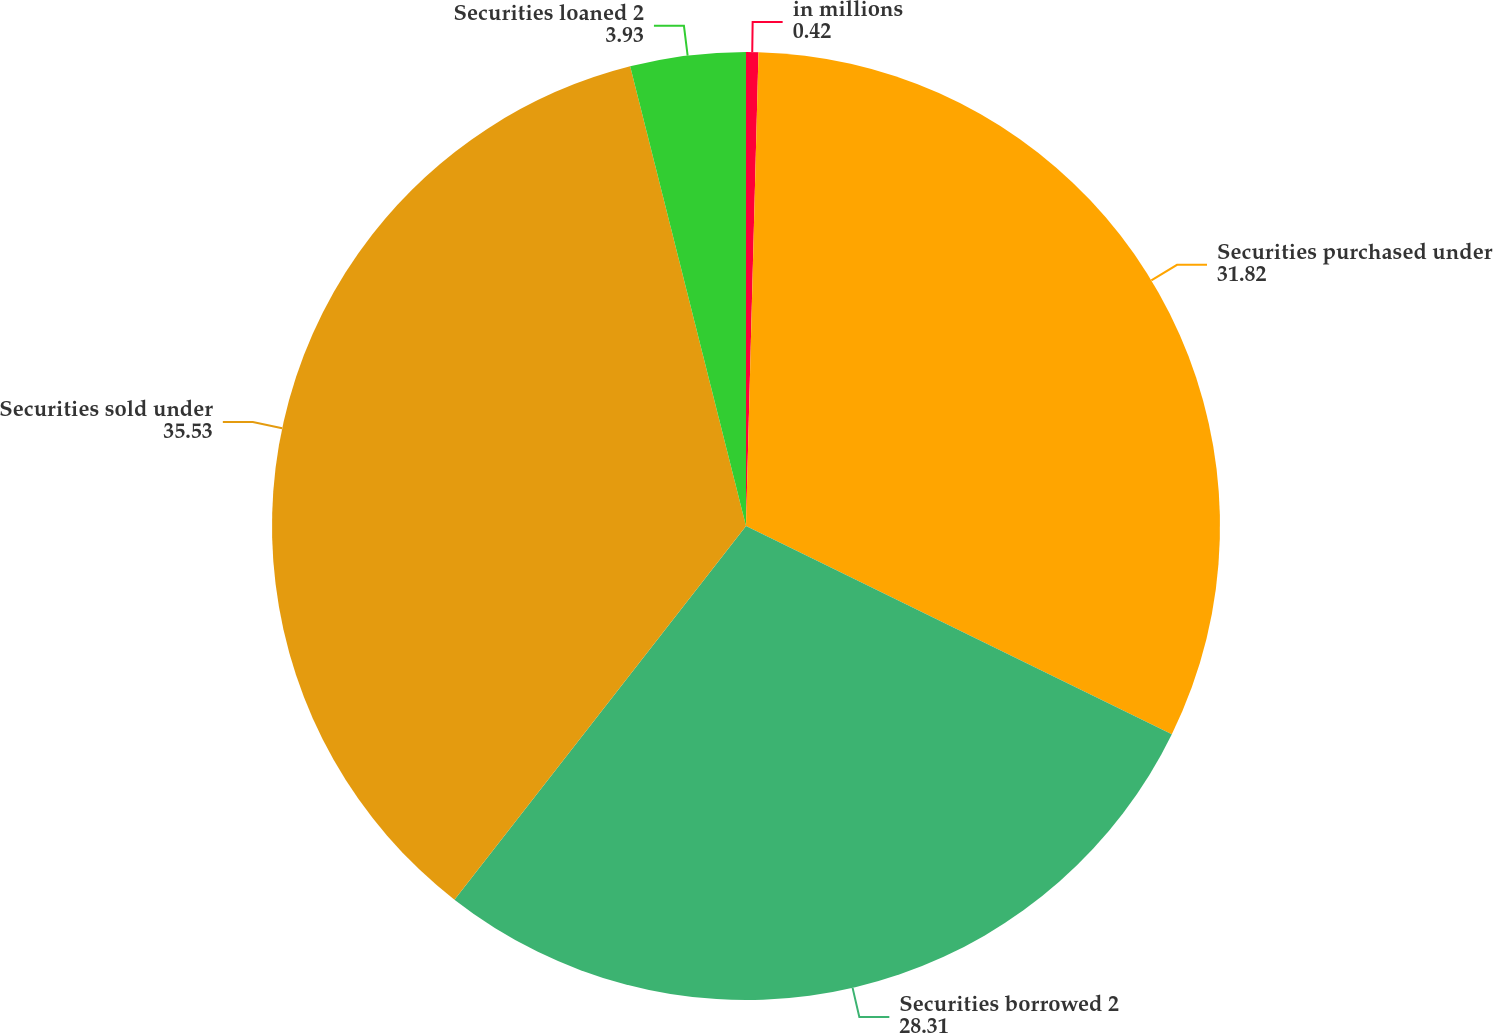Convert chart to OTSL. <chart><loc_0><loc_0><loc_500><loc_500><pie_chart><fcel>in millions<fcel>Securities purchased under<fcel>Securities borrowed 2<fcel>Securities sold under<fcel>Securities loaned 2<nl><fcel>0.42%<fcel>31.82%<fcel>28.31%<fcel>35.53%<fcel>3.93%<nl></chart> 